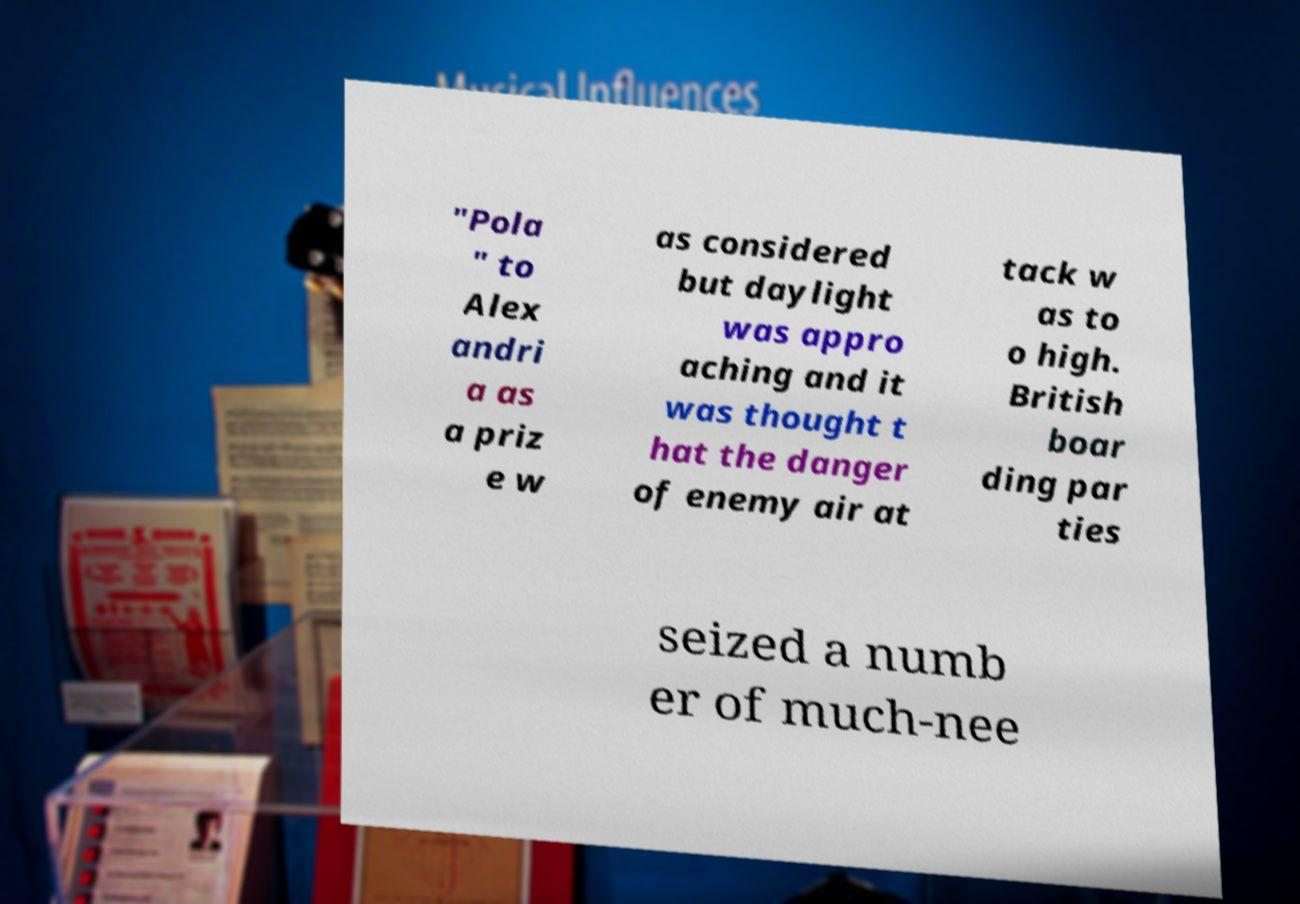For documentation purposes, I need the text within this image transcribed. Could you provide that? "Pola " to Alex andri a as a priz e w as considered but daylight was appro aching and it was thought t hat the danger of enemy air at tack w as to o high. British boar ding par ties seized a numb er of much-nee 